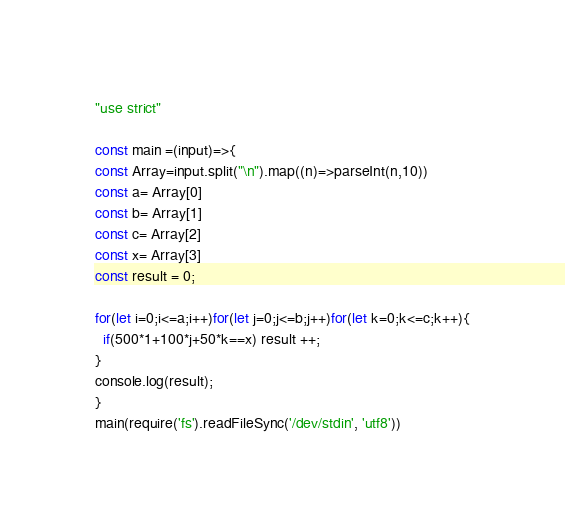<code> <loc_0><loc_0><loc_500><loc_500><_JavaScript_>"use strict"

const main =(input)=>{
const Array=input.split("\n").map((n)=>parseInt(n,10))
const a= Array[0]
const b= Array[1]
const c= Array[2]
const x= Array[3]
const result = 0;

for(let i=0;i<=a;i++)for(let j=0;j<=b;j++)for(let k=0;k<=c;k++){
  if(500*1+100*j+50*k==x) result ++;
}
console.log(result);
}
main(require('fs').readFileSync('/dev/stdin', 'utf8'))
</code> 